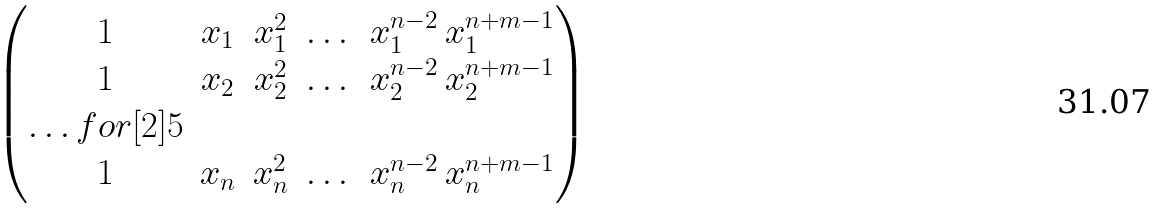<formula> <loc_0><loc_0><loc_500><loc_500>\begin{pmatrix} 1 & x _ { 1 } & x _ { 1 } ^ { 2 } & \dots & x _ { 1 } ^ { n - 2 } \, x _ { 1 } ^ { n + m - 1 } \\ 1 & x _ { 2 } & x _ { 2 } ^ { 2 } & \dots & x _ { 2 } ^ { n - 2 } \, x _ { 2 } ^ { n + m - 1 } \\ \hdots f o r [ 2 ] { 5 } \\ 1 & x _ { n } & x _ { n } ^ { 2 } & \dots & x _ { n } ^ { n - 2 } \, x _ { n } ^ { n + m - 1 } \end{pmatrix}</formula> 